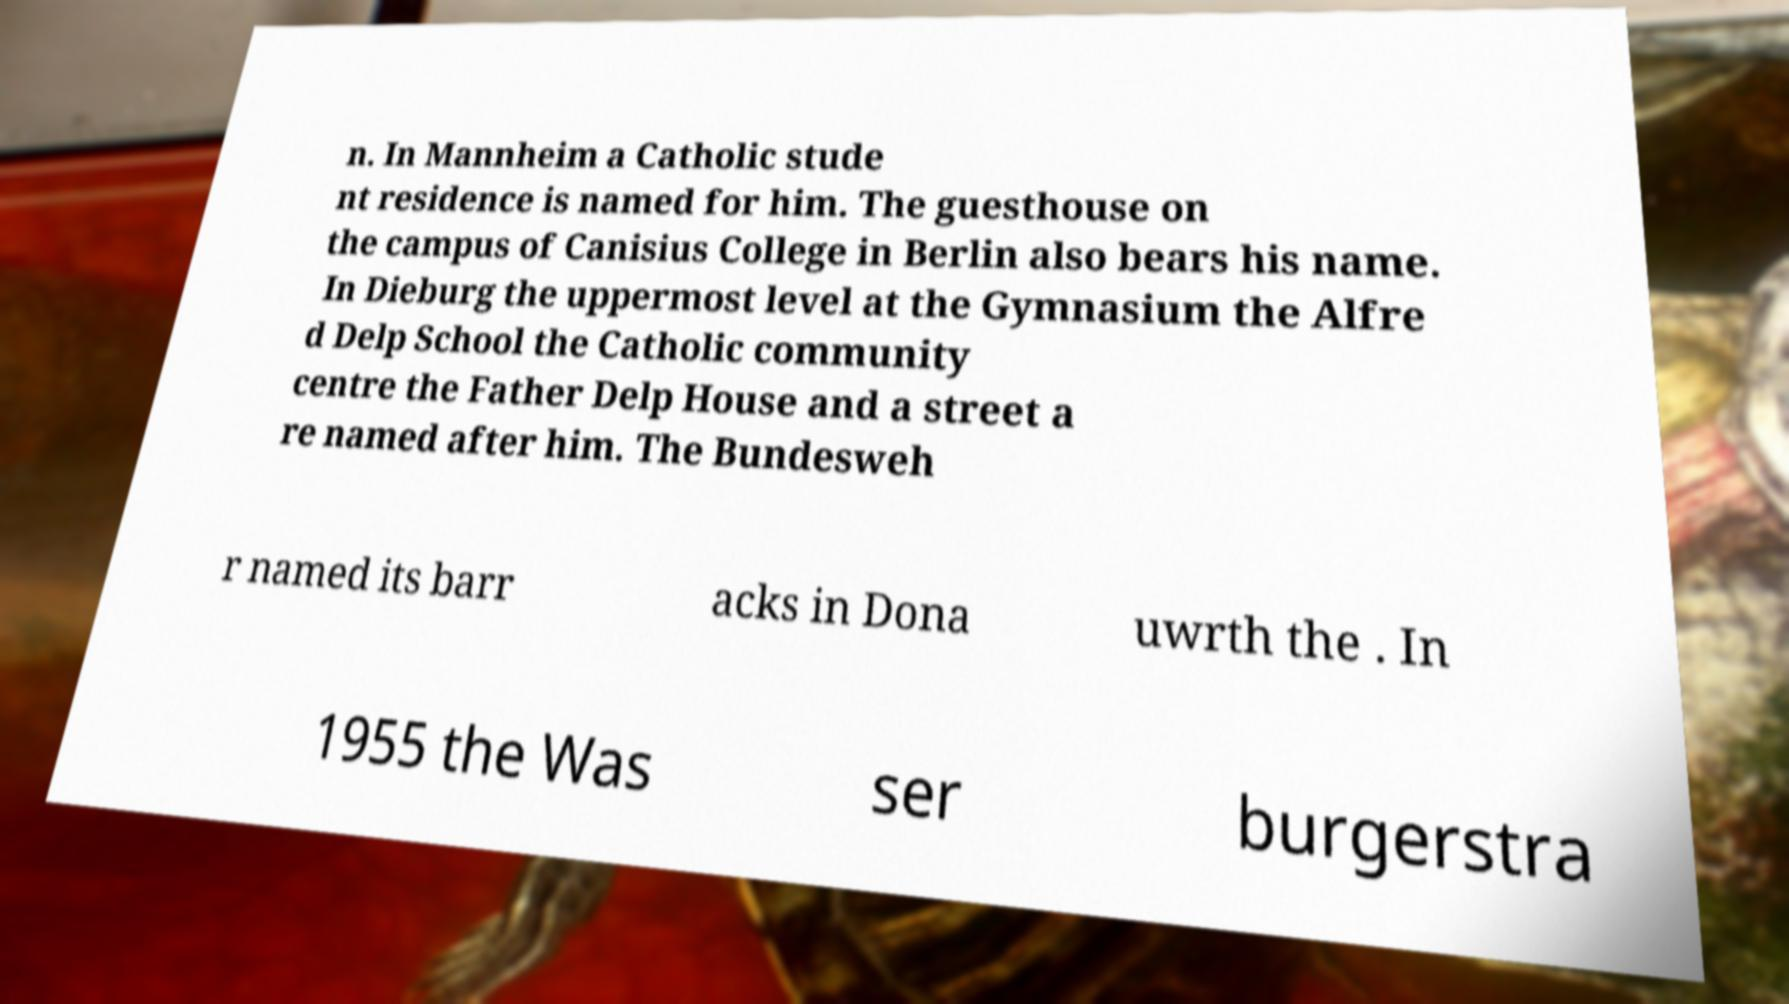Please identify and transcribe the text found in this image. n. In Mannheim a Catholic stude nt residence is named for him. The guesthouse on the campus of Canisius College in Berlin also bears his name. In Dieburg the uppermost level at the Gymnasium the Alfre d Delp School the Catholic community centre the Father Delp House and a street a re named after him. The Bundesweh r named its barr acks in Dona uwrth the . In 1955 the Was ser burgerstra 